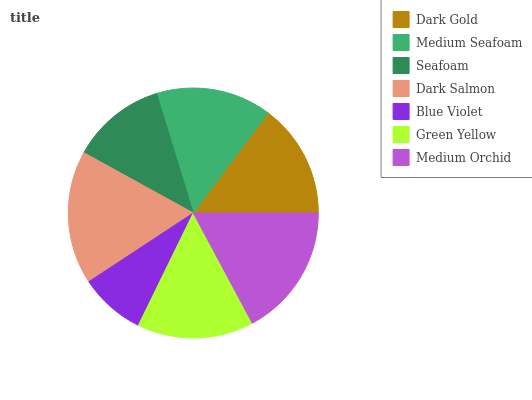Is Blue Violet the minimum?
Answer yes or no. Yes. Is Dark Salmon the maximum?
Answer yes or no. Yes. Is Medium Seafoam the minimum?
Answer yes or no. No. Is Medium Seafoam the maximum?
Answer yes or no. No. Is Medium Seafoam greater than Dark Gold?
Answer yes or no. Yes. Is Dark Gold less than Medium Seafoam?
Answer yes or no. Yes. Is Dark Gold greater than Medium Seafoam?
Answer yes or no. No. Is Medium Seafoam less than Dark Gold?
Answer yes or no. No. Is Medium Seafoam the high median?
Answer yes or no. Yes. Is Medium Seafoam the low median?
Answer yes or no. Yes. Is Blue Violet the high median?
Answer yes or no. No. Is Medium Orchid the low median?
Answer yes or no. No. 